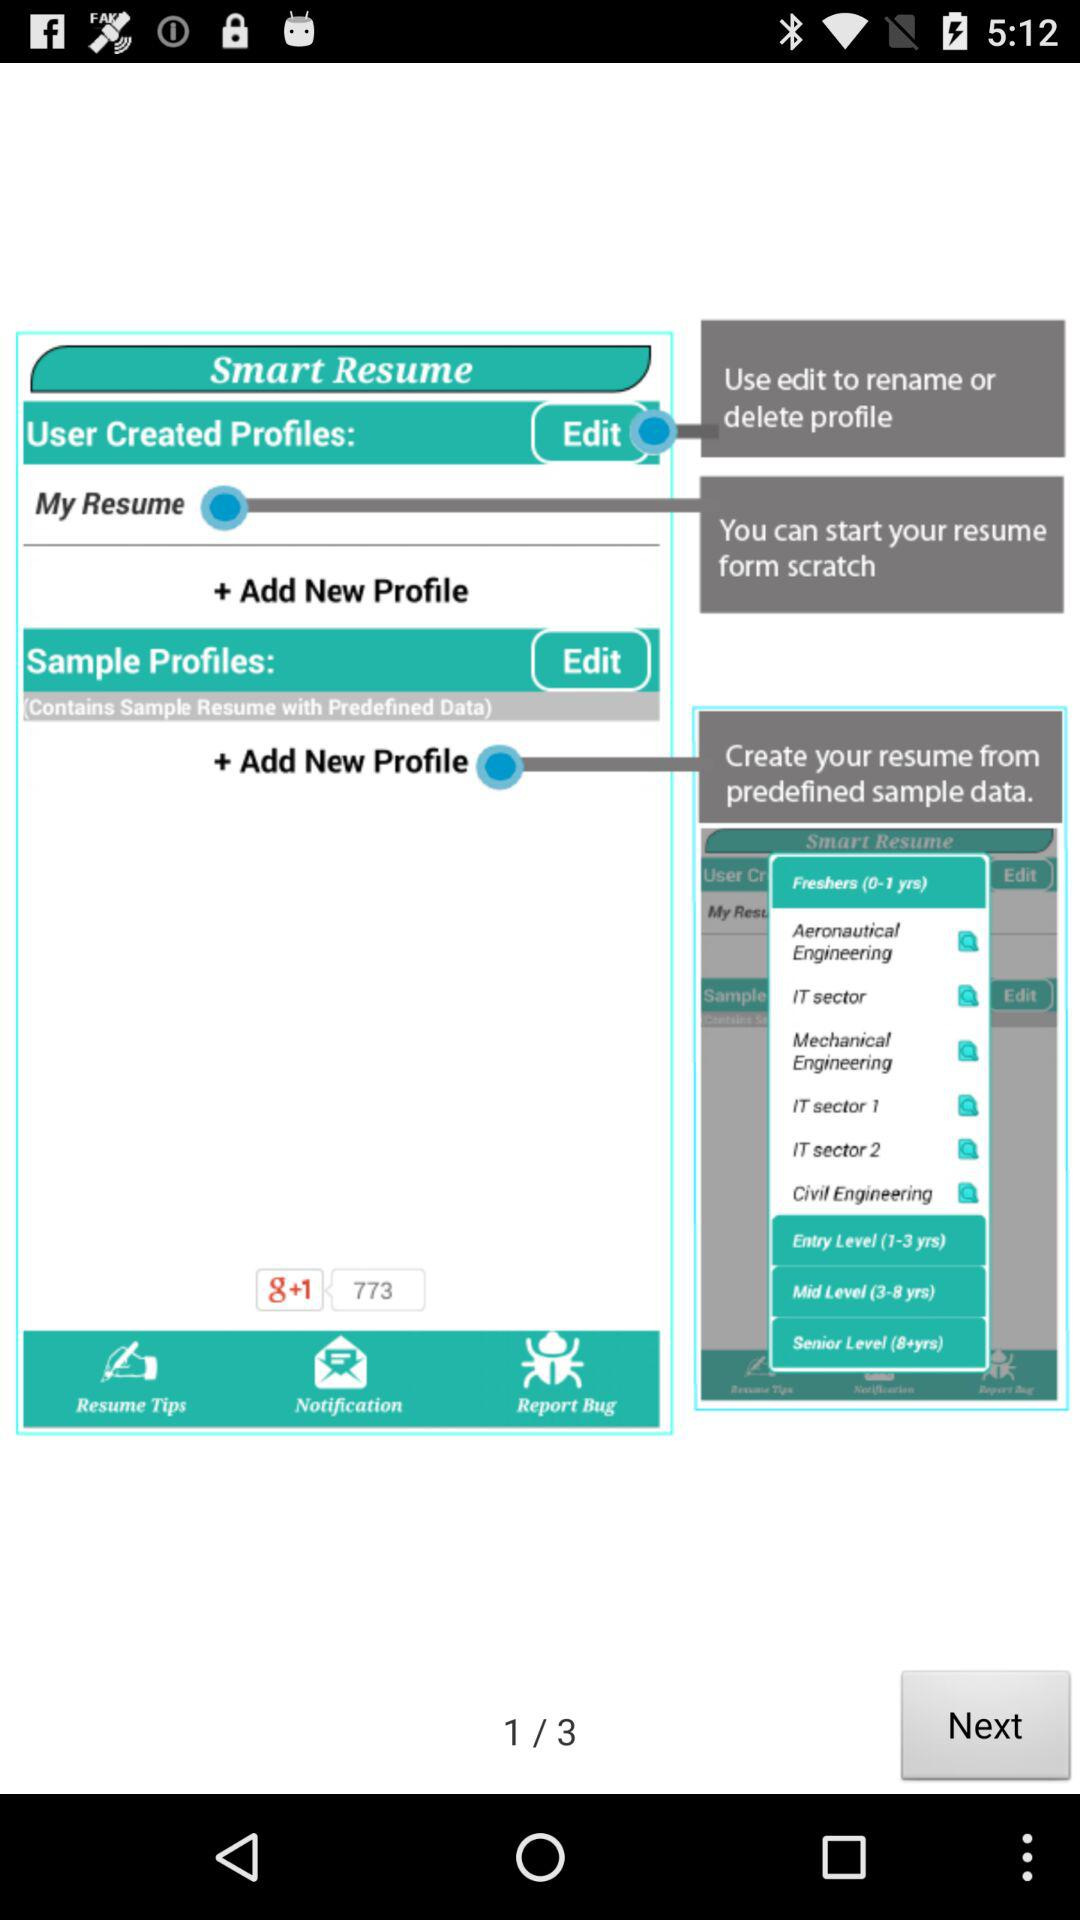How many total pages are there? The total pages are 3. 